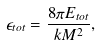<formula> <loc_0><loc_0><loc_500><loc_500>\epsilon _ { t o t } = \frac { 8 \pi E _ { t o t } } { k M ^ { 2 } } ,</formula> 